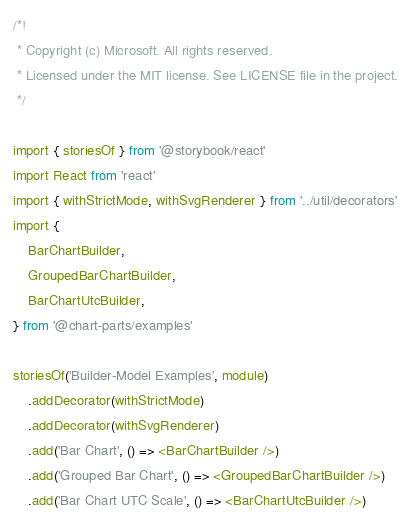Convert code to text. <code><loc_0><loc_0><loc_500><loc_500><_TypeScript_>/*!
 * Copyright (c) Microsoft. All rights reserved.
 * Licensed under the MIT license. See LICENSE file in the project.
 */

import { storiesOf } from '@storybook/react'
import React from 'react'
import { withStrictMode, withSvgRenderer } from '../util/decorators'
import {
	BarChartBuilder,
	GroupedBarChartBuilder,
	BarChartUtcBuilder,
} from '@chart-parts/examples'

storiesOf('Builder-Model Examples', module)
	.addDecorator(withStrictMode)
	.addDecorator(withSvgRenderer)
	.add('Bar Chart', () => <BarChartBuilder />)
	.add('Grouped Bar Chart', () => <GroupedBarChartBuilder />)
	.add('Bar Chart UTC Scale', () => <BarChartUtcBuilder />)
</code> 